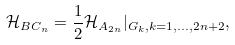<formula> <loc_0><loc_0><loc_500><loc_500>\mathcal { H } _ { B C _ { n } } = \frac { 1 } { 2 } \mathcal { H } _ { A _ { 2 n } } | _ { G _ { k } , k = 1 , \dots , 2 n + 2 } ,</formula> 